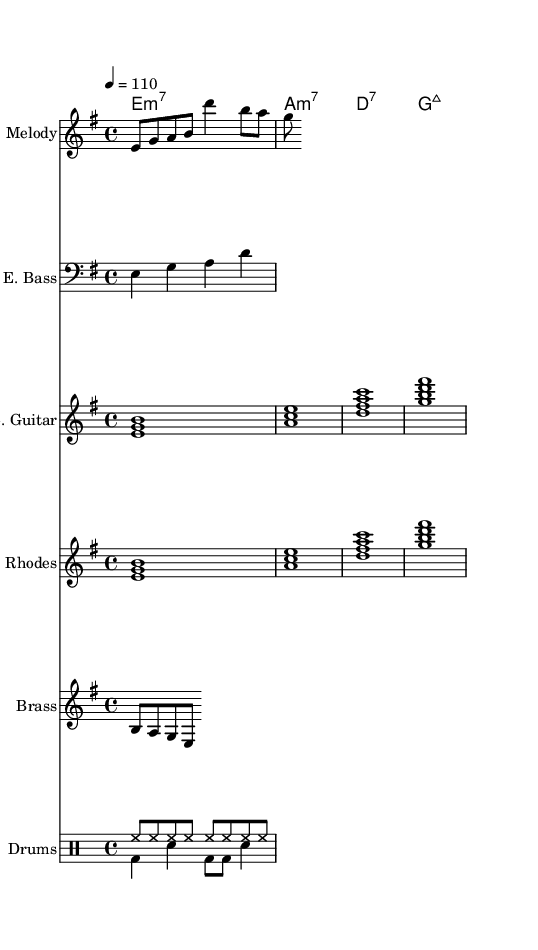What is the key signature of this music? The key signature is based on the note E minor, which includes one sharp (F#). This is indicated at the beginning of the score.
Answer: E minor What is the time signature of this music? The time signature is indicated at the beginning of the score as 4/4, meaning there are four beats in each measure and the quarter note gets one beat.
Answer: 4/4 What is the tempo marking of this music? The tempo marking in the score states "4 = 110," indicating that there are 110 beats per minute. This tells us how fast the music should be played.
Answer: 110 How many instruments are represented in this score? The score includes five different instruments: Melody, Electric Bass, Electric Guitar, Rhodes Piano, and Brass, plus a Drum Staff. So, that makes it a total of six.
Answer: Six What is the function of the brass section in this music? The brass section plays a riff that likely adds emphasis and texture to the overall sound, typically found in Funk music, which often features prominent brass sections for that signature groove.
Answer: Riff What type of grooves can be identified in the drum patterns? The drum patterns show a combination of hi-hat and bass drum, with an alternating snare, creating a classic Funk groove that supports the rhythm section and drives the piece.
Answer: Classic Funk groove What quality does the Rhodes Piano add to the music? The Rhodes Piano provides a smooth, electric sound that complements the melody and adds to the rich, funky texture typical of 80s Funk fusion.
Answer: Smooth electric sound 